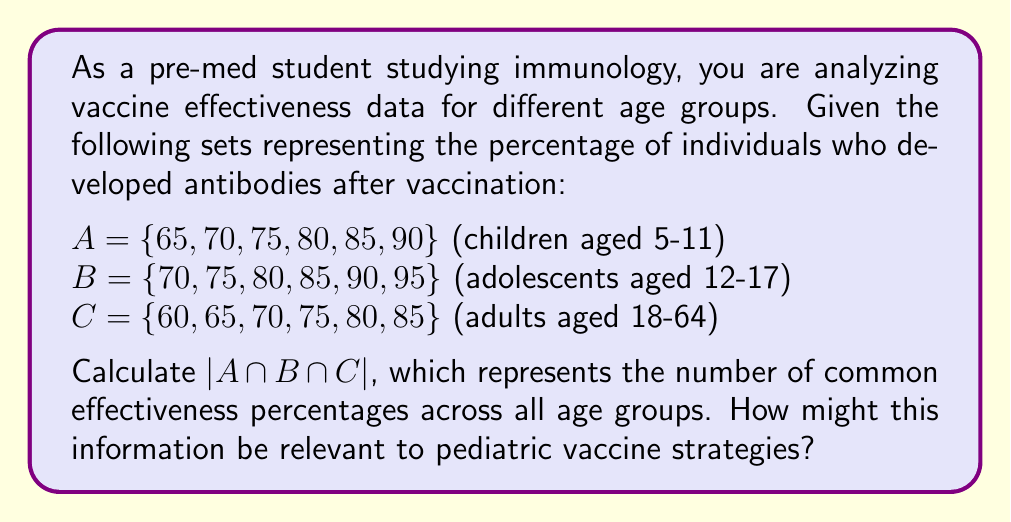Show me your answer to this math problem. To solve this problem, we need to find the intersection of sets A, B, and C, and then determine the cardinality (number of elements) of the resulting set.

Step 1: Identify the elements that appear in all three sets.
$A \cap B \cap C = \{x | x \in A \text{ and } x \in B \text{ and } x \in C\}$

By inspection:
- 70 appears in all three sets
- 75 appears in all three sets
- 80 appears in all three sets
- 85 appears in all three sets

Step 2: Write the intersection set.
$A \cap B \cap C = \{70, 75, 80, 85\}$

Step 3: Calculate the cardinality of the intersection set.
$|A \cap B \cap C| = 4$

Relevance to pediatric vaccine strategies:
This result shows that there are four effectiveness percentages common across all age groups. As a future pediatrician, this information is crucial for understanding that certain vaccine effectiveness levels are consistent across different age groups. This could inform decisions about vaccine administration schedules, dosage adjustments, or the need for booster shots in pediatric populations. It also suggests that these effectiveness levels might be achievable in different age groups, which could be valuable when communicating with parents about vaccine efficacy and safety.
Answer: $|A \cap B \cap C| = 4$ 